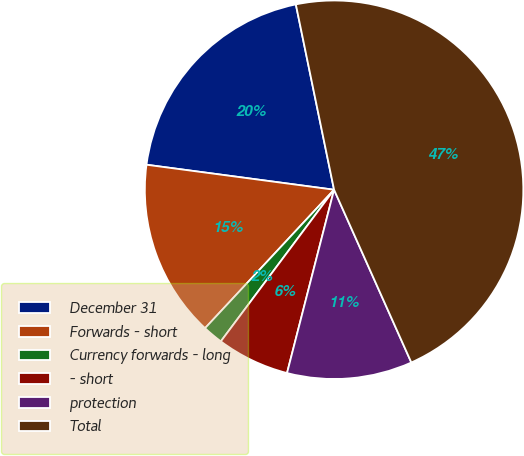<chart> <loc_0><loc_0><loc_500><loc_500><pie_chart><fcel>December 31<fcel>Forwards - short<fcel>Currency forwards - long<fcel>- short<fcel>protection<fcel>Total<nl><fcel>19.65%<fcel>15.17%<fcel>1.73%<fcel>6.21%<fcel>10.69%<fcel>46.54%<nl></chart> 